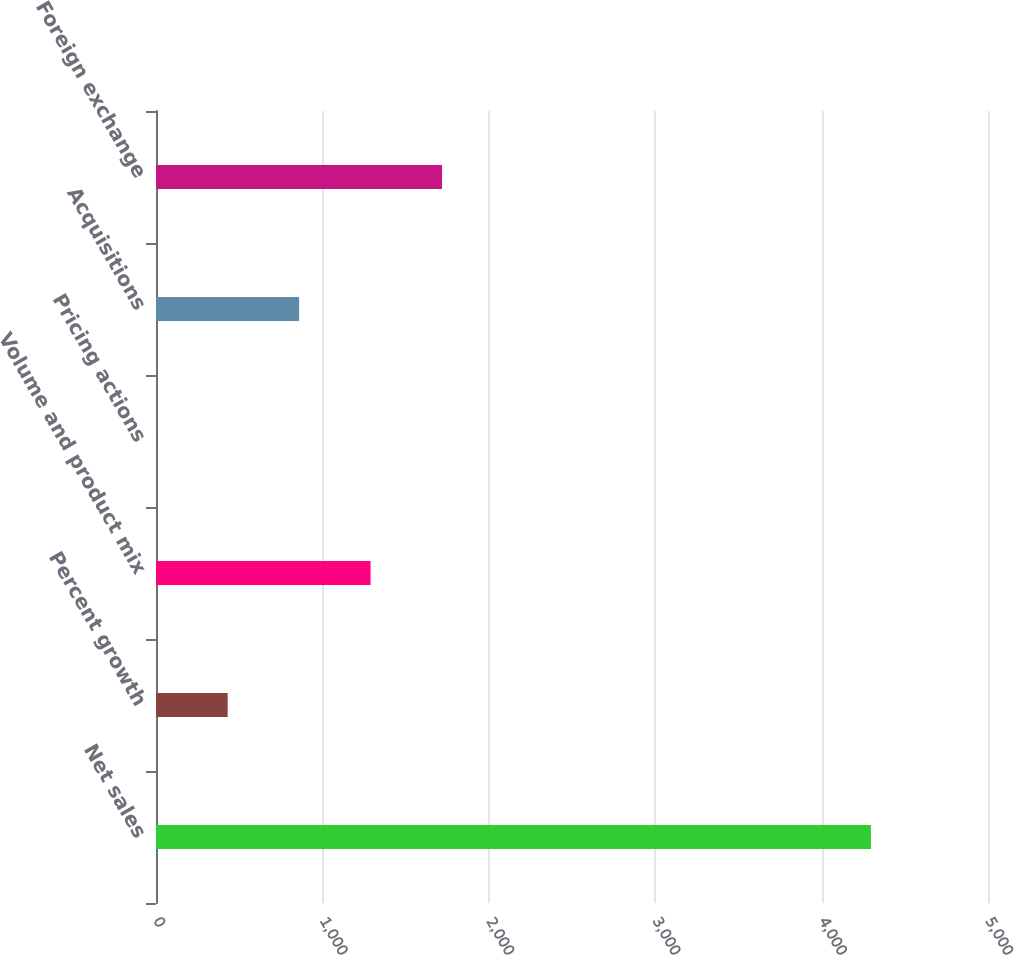Convert chart. <chart><loc_0><loc_0><loc_500><loc_500><bar_chart><fcel>Net sales<fcel>Percent growth<fcel>Volume and product mix<fcel>Pricing actions<fcel>Acquisitions<fcel>Foreign exchange<nl><fcel>4296.3<fcel>430.62<fcel>1289.66<fcel>1.1<fcel>860.14<fcel>1719.18<nl></chart> 